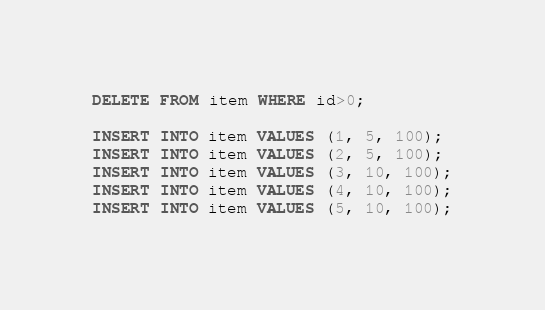<code> <loc_0><loc_0><loc_500><loc_500><_SQL_>DELETE FROM item WHERE id>0;

INSERT INTO item VALUES (1, 5, 100);
INSERT INTO item VALUES (2, 5, 100);
INSERT INTO item VALUES (3, 10, 100);
INSERT INTO item VALUES (4, 10, 100);
INSERT INTO item VALUES (5, 10, 100);</code> 